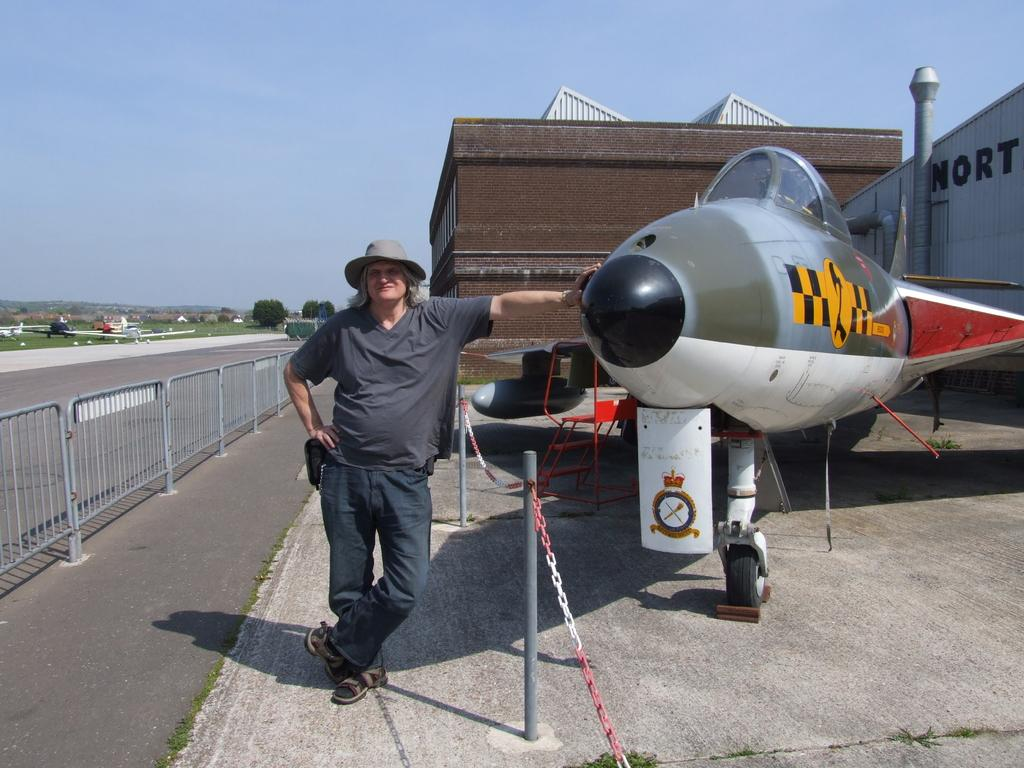<image>
Present a compact description of the photo's key features. A person leans on the nose of a military aircraft with the number 2 painted in a yellow circle on the side. 